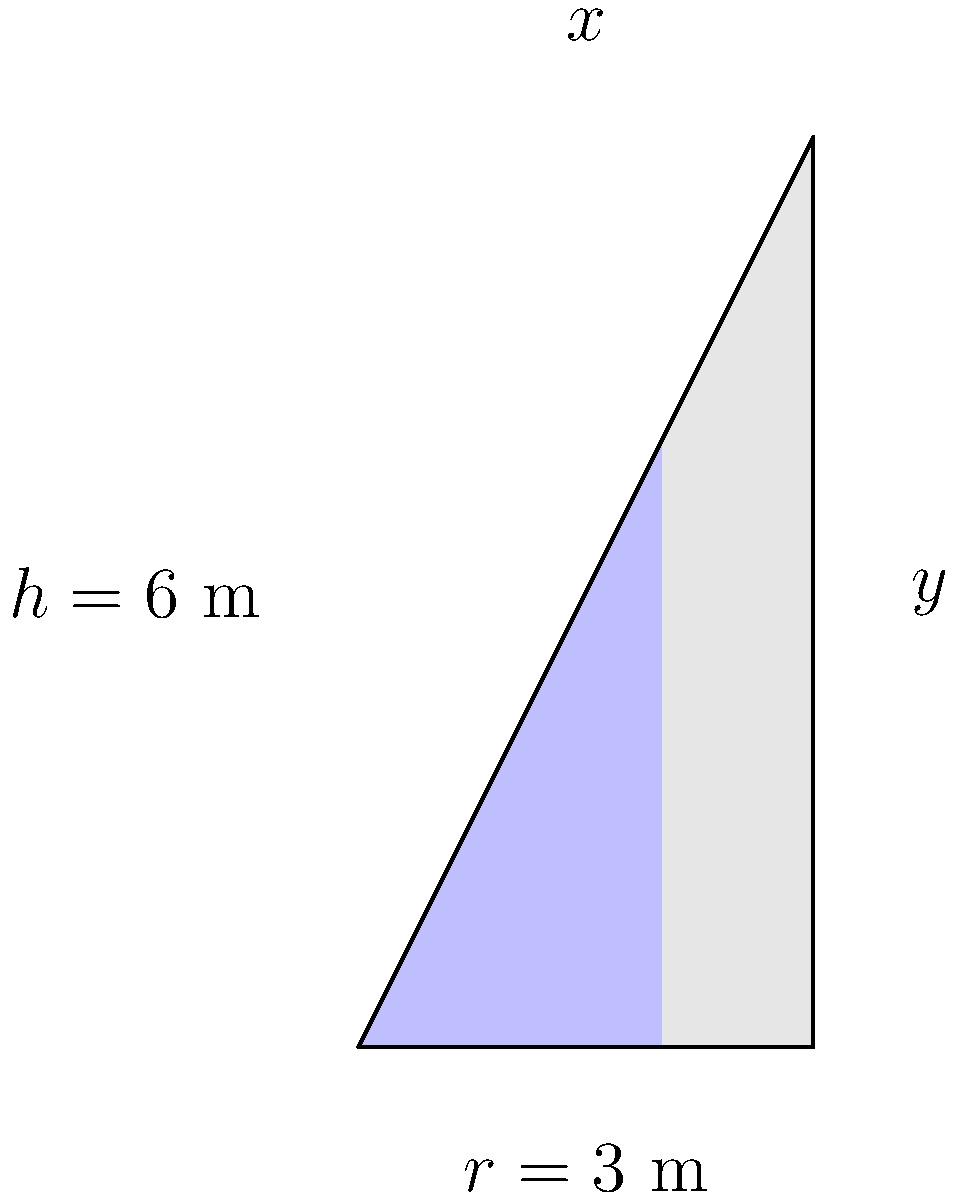A conical water tank has a height of 6 meters and a radius of 3 meters at the base. The tank is currently filled to two-thirds of its height. Calculate the work done in pumping all the water out of the top of the tank, given that water weighs 9800 N/m³. Express your answer in Joules. To solve this problem, we'll follow these steps:

1) First, we need to set up the integral for the work done. The general formula is:

   $$W = \int_{y_1}^{y_2} F(y) \cdot dy$$

   where $F(y)$ is the force needed to lift a thin disk of water at height $y$.

2) The force $F(y)$ is the weight of the water, which is density times volume:

   $$F(y) = 9800 \cdot \pi r(y)^2 \cdot dy$$

3) We need to express $r(y)$ in terms of $y$. From the similar triangles in the cone:

   $$\frac{r(y)}{3} = \frac{6-y}{6}$$

   So, $$r(y) = 3 - \frac{y}{2}$$

4) Substituting this into our force equation:

   $$F(y) = 9800 \cdot \pi (3 - \frac{y}{2})^2 \cdot dy$$

5) Now we can set up our integral. We're pumping from $y=4$ (2/3 of 6) to $y=6$:

   $$W = \int_{4}^{6} 9800 \cdot \pi (3 - \frac{y}{2})^2 \cdot dy$$

6) Simplifying the integrand:

   $$W = 9800\pi \int_{4}^{6} (9 - 3y + \frac{y^2}{4}) \cdot dy$$

7) Integrating:

   $$W = 9800\pi [9y - \frac{3y^2}{2} + \frac{y^3}{12}]_{4}^{6}$$

8) Evaluating the limits:

   $$W = 9800\pi [(54 - 54 + 18) - (36 - 32 + \frac{64}{12})]$$
   $$W = 9800\pi [18 - (36 - 32 + \frac{16}{3})]$$
   $$W = 9800\pi [18 - (4 + \frac{16}{3})]$$
   $$W = 9800\pi [18 - \frac{28}{3}]$$
   $$W = 9800\pi \cdot \frac{26}{3}$$

9) Calculating the final result:

   $$W = 265720\pi \approx 834,513.96 \text{ J}$$
Answer: 834,514 J 